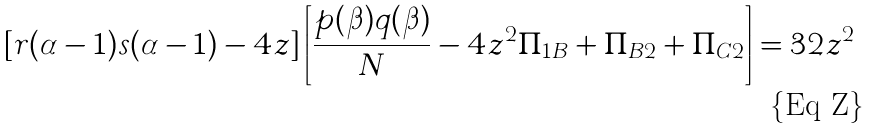Convert formula to latex. <formula><loc_0><loc_0><loc_500><loc_500>[ r ( \alpha - 1 ) s ( \alpha - 1 ) - 4 z ] \left [ \frac { p ( \beta ) q ( \beta ) } { N } - 4 z ^ { 2 } \Pi _ { 1 B } + \Pi _ { B 2 } + \Pi _ { C 2 } \right ] = 3 2 z ^ { 2 }</formula> 